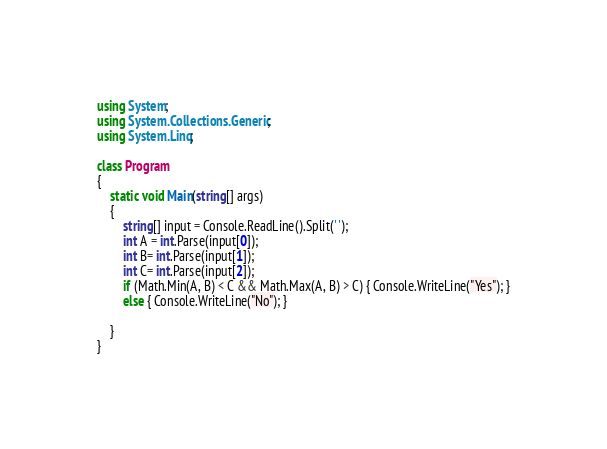<code> <loc_0><loc_0><loc_500><loc_500><_C#_>using System;
using System.Collections.Generic;
using System.Linq;

class Program
{
    static void Main(string[] args)
    {
        string[] input = Console.ReadLine().Split(' ');
        int A = int.Parse(input[0]);
        int B= int.Parse(input[1]);
        int C= int.Parse(input[2]);
        if (Math.Min(A, B) < C && Math.Max(A, B) > C) { Console.WriteLine("Yes"); }
        else { Console.WriteLine("No"); }
        
    }
}</code> 